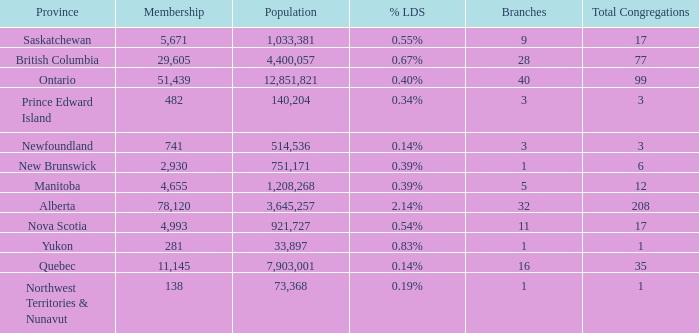What's the sum of population when the membership is 51,439 for fewer than 40 branches? None. 